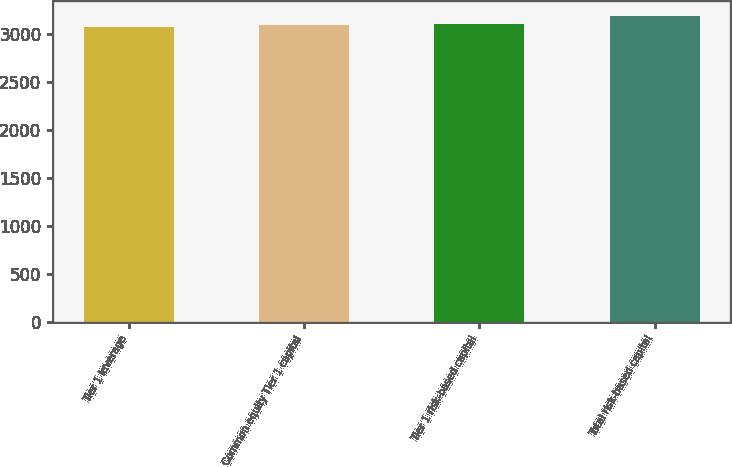Convert chart. <chart><loc_0><loc_0><loc_500><loc_500><bar_chart><fcel>Tier 1 leverage<fcel>Common equity Tier 1 capital<fcel>Tier 1 risk-based capital<fcel>Total risk-based capital<nl><fcel>3075<fcel>3086<fcel>3097<fcel>3185<nl></chart> 